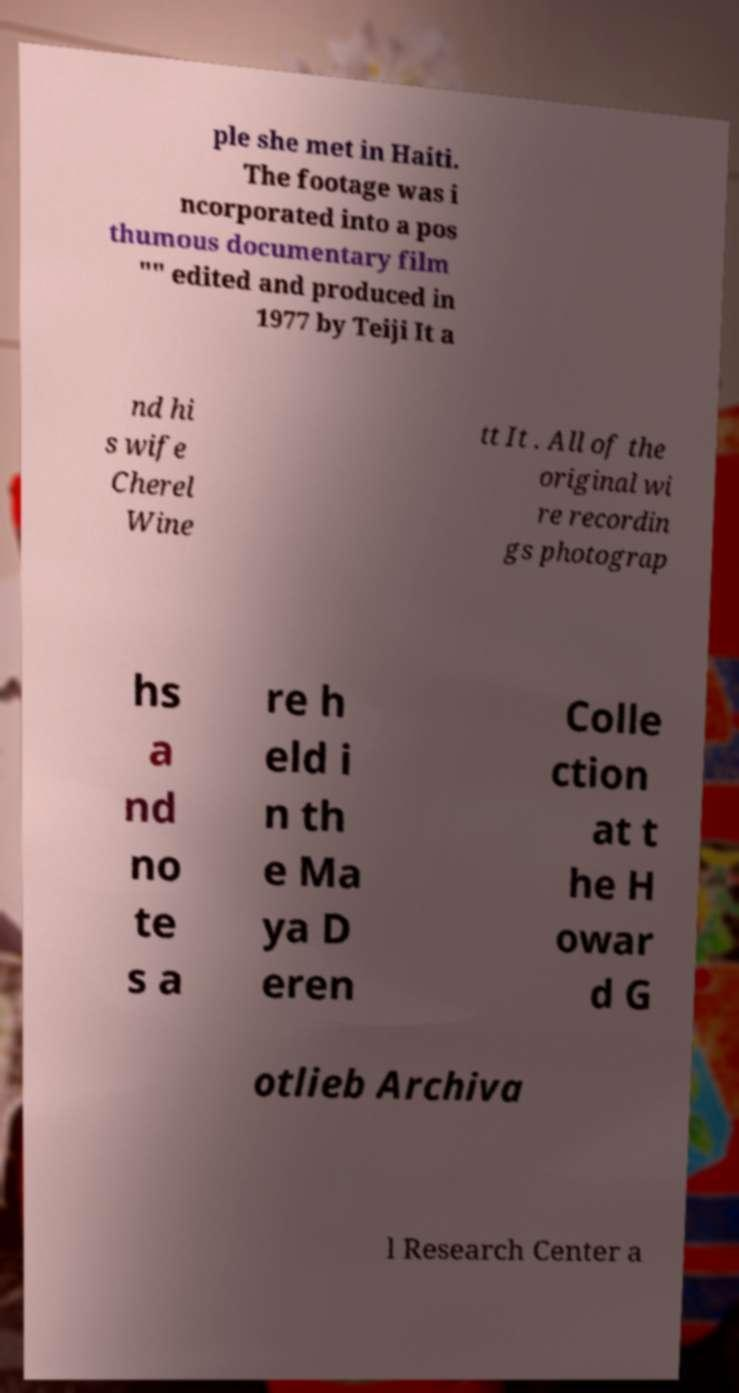Can you accurately transcribe the text from the provided image for me? ple she met in Haiti. The footage was i ncorporated into a pos thumous documentary film "" edited and produced in 1977 by Teiji It a nd hi s wife Cherel Wine tt It . All of the original wi re recordin gs photograp hs a nd no te s a re h eld i n th e Ma ya D eren Colle ction at t he H owar d G otlieb Archiva l Research Center a 